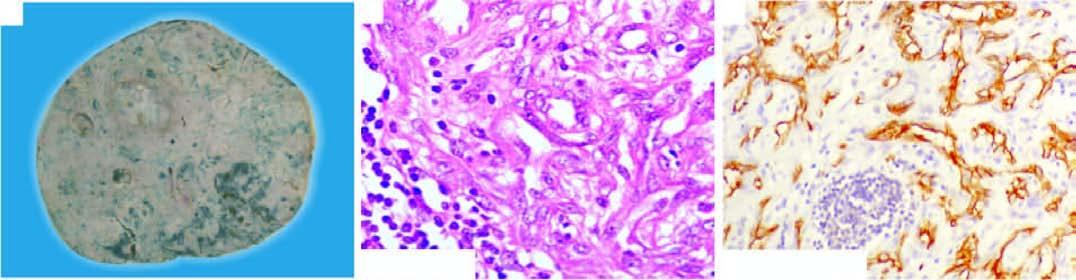what show proliferation of moderately pleomorphic anaplastic cells?
Answer the question using a single word or phrase. The tumour cells 